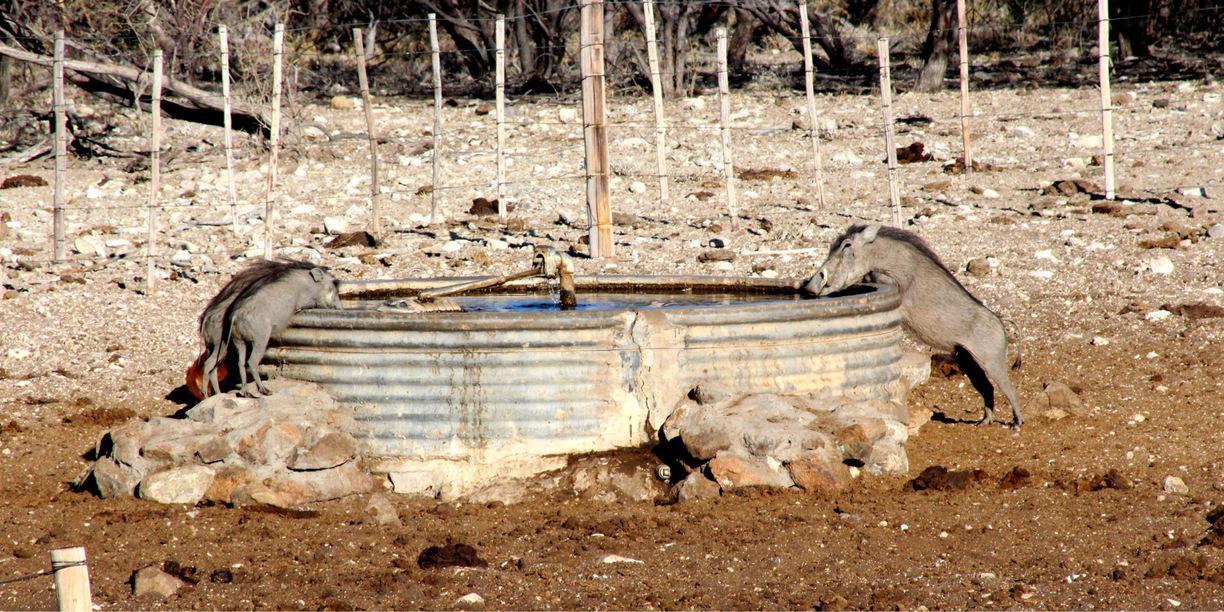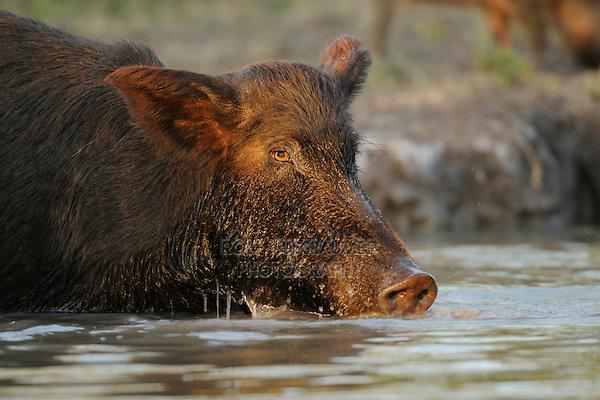The first image is the image on the left, the second image is the image on the right. Assess this claim about the two images: "At least one animal in one of the images in near a watery area.". Correct or not? Answer yes or no. Yes. The first image is the image on the left, the second image is the image on the right. Analyze the images presented: Is the assertion "Each image shows exactly one warthog, which is standing with its front knees on the ground." valid? Answer yes or no. No. 